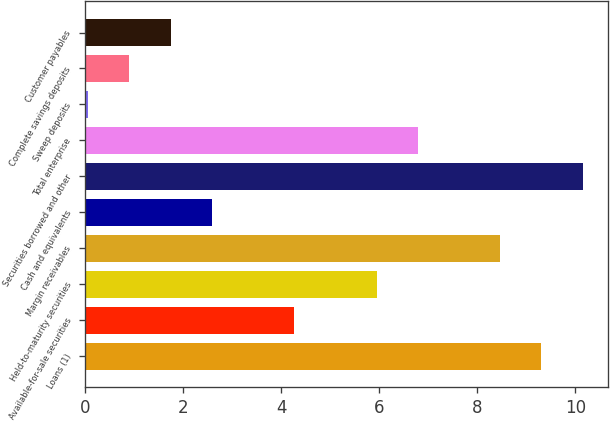Convert chart. <chart><loc_0><loc_0><loc_500><loc_500><bar_chart><fcel>Loans (1)<fcel>Available-for-sale securities<fcel>Held-to-maturity securities<fcel>Margin receivables<fcel>Cash and equivalents<fcel>Securities borrowed and other<fcel>Total enterprise<fcel>Sweep deposits<fcel>Complete savings deposits<fcel>Customer payables<nl><fcel>9.31<fcel>4.27<fcel>5.95<fcel>8.47<fcel>2.59<fcel>10.15<fcel>6.79<fcel>0.07<fcel>0.91<fcel>1.75<nl></chart> 